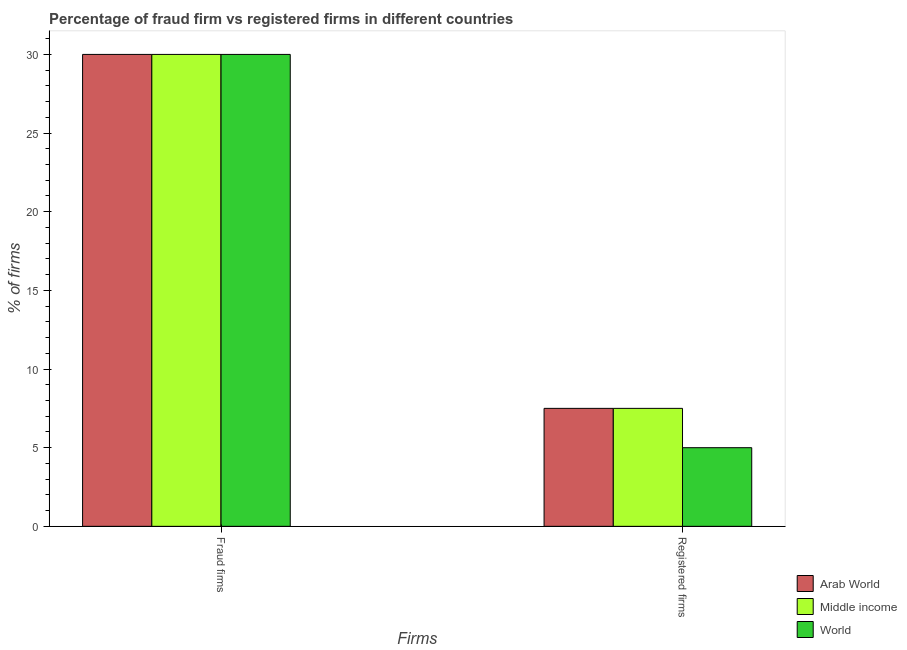How many different coloured bars are there?
Provide a short and direct response. 3. How many groups of bars are there?
Provide a succinct answer. 2. Are the number of bars per tick equal to the number of legend labels?
Give a very brief answer. Yes. How many bars are there on the 1st tick from the right?
Keep it short and to the point. 3. What is the label of the 2nd group of bars from the left?
Offer a very short reply. Registered firms. What is the percentage of registered firms in Arab World?
Make the answer very short. 7.5. In which country was the percentage of registered firms maximum?
Offer a terse response. Arab World. In which country was the percentage of fraud firms minimum?
Provide a short and direct response. Arab World. What is the total percentage of registered firms in the graph?
Make the answer very short. 20. What is the difference between the percentage of registered firms in World and that in Middle income?
Keep it short and to the point. -2.5. What is the difference between the percentage of fraud firms and percentage of registered firms in World?
Provide a succinct answer. 25. In how many countries, is the percentage of fraud firms greater than 15 %?
Offer a very short reply. 3. What is the ratio of the percentage of registered firms in World to that in Middle income?
Your answer should be very brief. 0.67. In how many countries, is the percentage of registered firms greater than the average percentage of registered firms taken over all countries?
Ensure brevity in your answer.  2. What does the 1st bar from the right in Fraud firms represents?
Your answer should be very brief. World. Are all the bars in the graph horizontal?
Keep it short and to the point. No. Where does the legend appear in the graph?
Offer a terse response. Bottom right. How many legend labels are there?
Your response must be concise. 3. What is the title of the graph?
Give a very brief answer. Percentage of fraud firm vs registered firms in different countries. Does "Uganda" appear as one of the legend labels in the graph?
Ensure brevity in your answer.  No. What is the label or title of the X-axis?
Provide a succinct answer. Firms. What is the label or title of the Y-axis?
Make the answer very short. % of firms. What is the % of firms of Arab World in Fraud firms?
Your response must be concise. 30. What is the % of firms in World in Fraud firms?
Keep it short and to the point. 30. What is the % of firms of Middle income in Registered firms?
Make the answer very short. 7.5. What is the % of firms of World in Registered firms?
Your response must be concise. 5. Across all Firms, what is the maximum % of firms in World?
Ensure brevity in your answer.  30. Across all Firms, what is the minimum % of firms of Arab World?
Make the answer very short. 7.5. Across all Firms, what is the minimum % of firms of Middle income?
Your response must be concise. 7.5. Across all Firms, what is the minimum % of firms of World?
Provide a succinct answer. 5. What is the total % of firms of Arab World in the graph?
Give a very brief answer. 37.5. What is the total % of firms of Middle income in the graph?
Offer a very short reply. 37.5. What is the difference between the % of firms of Arab World in Fraud firms and that in Registered firms?
Your response must be concise. 22.5. What is the difference between the % of firms of World in Fraud firms and that in Registered firms?
Make the answer very short. 25. What is the average % of firms of Arab World per Firms?
Give a very brief answer. 18.75. What is the average % of firms of Middle income per Firms?
Offer a terse response. 18.75. What is the difference between the % of firms of Arab World and % of firms of Middle income in Fraud firms?
Provide a short and direct response. 0. What is the difference between the % of firms of Arab World and % of firms of World in Fraud firms?
Offer a terse response. 0. What is the difference between the % of firms of Middle income and % of firms of World in Fraud firms?
Your answer should be very brief. 0. What is the difference between the % of firms of Arab World and % of firms of World in Registered firms?
Make the answer very short. 2.5. What is the difference between the % of firms of Middle income and % of firms of World in Registered firms?
Give a very brief answer. 2.5. What is the ratio of the % of firms in Arab World in Fraud firms to that in Registered firms?
Your response must be concise. 4. What is the ratio of the % of firms of World in Fraud firms to that in Registered firms?
Ensure brevity in your answer.  6. What is the difference between the highest and the second highest % of firms in World?
Provide a short and direct response. 25. What is the difference between the highest and the lowest % of firms in World?
Keep it short and to the point. 25. 